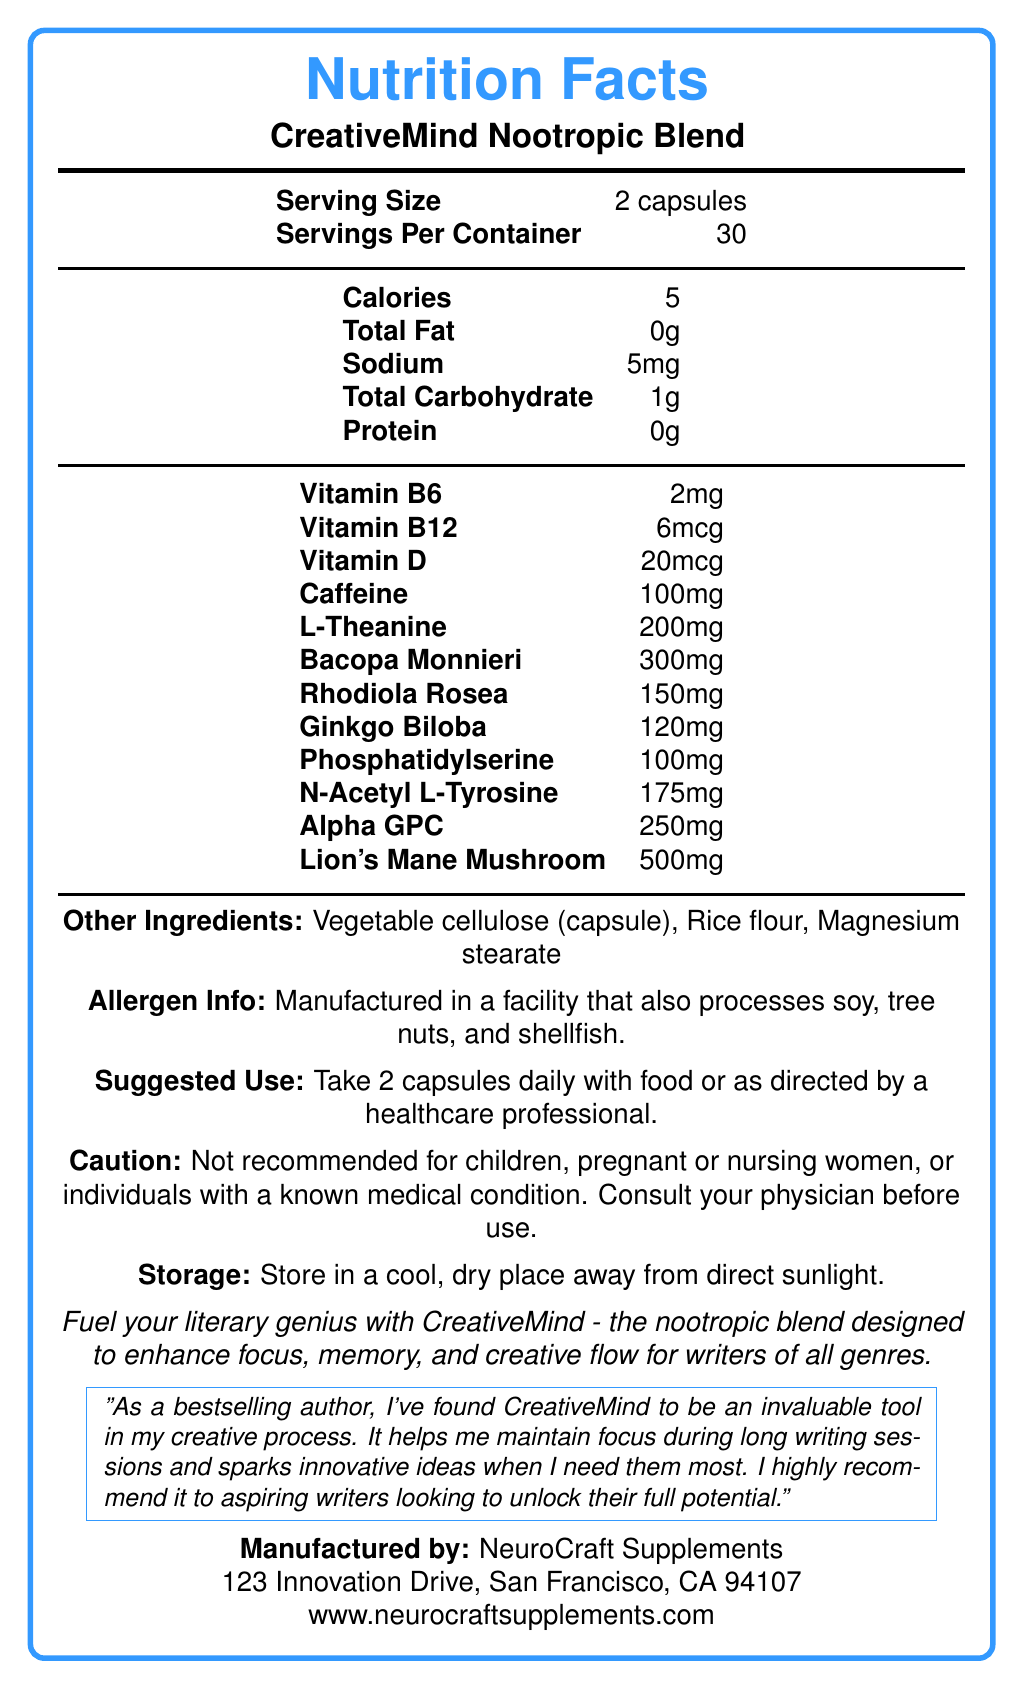What is the serving size of CreativeMind Nootropic Blend? According to the Nutrition Facts label, the serving size is specified as 2 capsules.
Answer: 2 capsules How many servings are there per container? The Nutrition Facts label indicates there are 30 servings per container.
Answer: 30 How many calories are in each serving? The label shows that each serving contains 5 calories.
Answer: 5 What is the amount of caffeine per serving? The Nutrition Facts label states that each serving contains 100mg of caffeine.
Answer: 100mg What ingredients are included under "Other Ingredients"? The label lists Vegetable cellulose (capsule), Rice flour, and Magnesium stearate under "Other Ingredients".
Answer: Vegetable cellulose (capsule), Rice flour, Magnesium stearate What is the suggested use for CreativeMind Nootropic Blend? The label suggests taking 2 capsules daily with food or as directed by a healthcare professional.
Answer: Take 2 capsules daily with food or as directed by a healthcare professional. What should people avoid when using this product? A. Children B. Pregnant or nursing women C. Those with a known medical condition D. All of the above The label cautions that the product is not recommended for children, pregnant or nursing women, or individuals with a known medical condition.
Answer: D. All of the above Which of these vitamins is not included in CreativeMind Nootropic Blend? A. Vitamin B6 B. Vitamin C C. Vitamin B12 D. Vitamin D The label lists Vitamin B6, Vitamin B12, and Vitamin D, but does not mention Vitamin C.
Answer: B. Vitamin C Does the product contain any protein? The Nutrition Facts label shows that the product contains 0g of protein.
Answer: No Is this product suitable for people with soy allergies? The allergen information states that the product is manufactured in a facility that also processes soy, tree nuts, and shellfish.
Answer: Possibly not Summarize the overall purpose and main benefits of CreativeMind Nootropic Blend. The document indicates that CreativeMind Nootropic Blend is marketed toward writers and other creative professionals, highlighting its ability to improve focus and creativity through a combination of nootropic ingredients.
Answer: CreativeMind Nootropic Blend is designed to enhance focus, memory, and creative flow for writers of all genres. The supplement contains ingredients aimed at boosting cognitive function. It includes vitamins, caffeine, and a blend of herbal extracts and amino acids. What is the exact address of the manufacturing company? The label specifies that NeuroCraft Supplements, the manufacturer, is located at 123 Innovation Drive, San Francisco, CA 94107.
Answer: 123 Innovation Drive, San Francisco, CA 94107 Are there any testimonials included in the document? The document includes a testimonial from a bestselling author who praises CreativeMind for helping with focus and generating innovative ideas.
Answer: Yes How much L-Theanine is present per serving? The Nutrition Facts label shows that each serving contains 200mg of L-Theanine.
Answer: 200mg Is CreativeMind suitable for children? The label cautions that the product is not recommended for children.
Answer: No What day of the week should I take the supplement? The document does not provide information regarding the specific days of the week for taking the supplement, only the serving size and suggested use.
Answer: Cannot be determined 